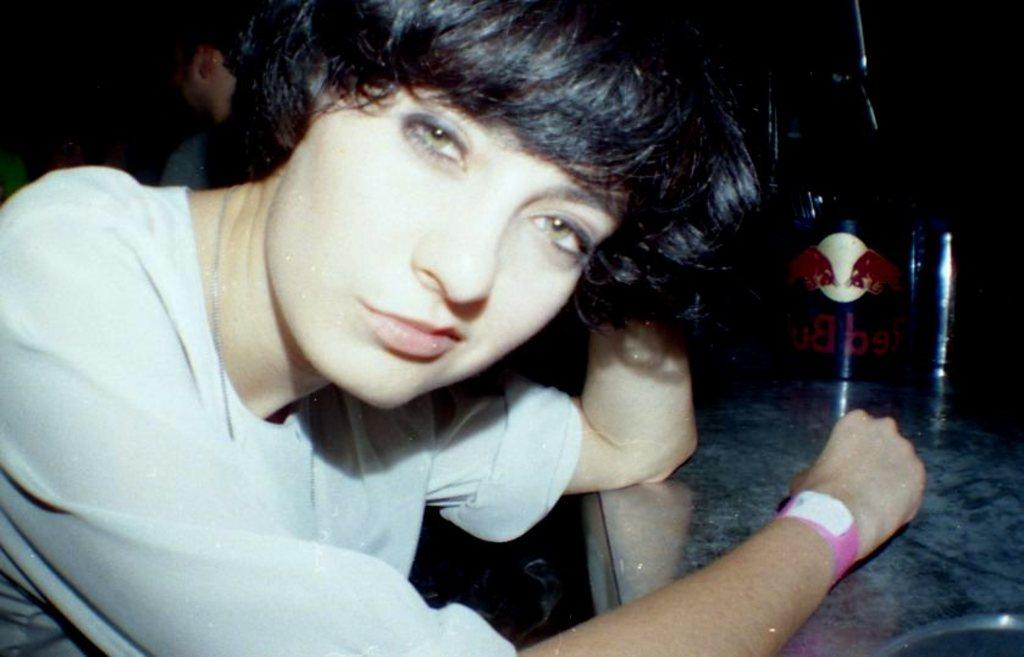What is the main subject in the foreground of the image? There is a person in the foreground of the image. What can be seen on the right side of the image? There is a table on the right side of the image. What is on the table? There are objects and text on the table. Can you describe the background of the image? The background is mostly dark, and there is another person in the background. What type of fruit is being played in rhythm by the person in the background? There is no fruit or rhythmic activity present in the image. 